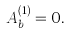<formula> <loc_0><loc_0><loc_500><loc_500>A ^ { ( 1 ) } _ { b } = 0 .</formula> 